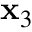Convert formula to latex. <formula><loc_0><loc_0><loc_500><loc_500>x _ { 3 }</formula> 